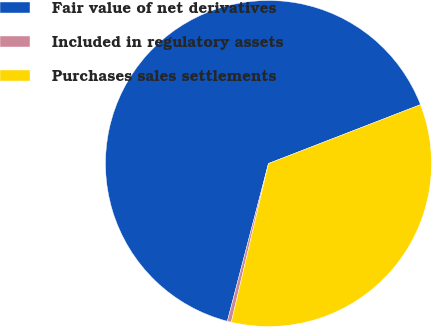Convert chart to OTSL. <chart><loc_0><loc_0><loc_500><loc_500><pie_chart><fcel>Fair value of net derivatives<fcel>Included in regulatory assets<fcel>Purchases sales settlements<nl><fcel>65.06%<fcel>0.4%<fcel>34.54%<nl></chart> 